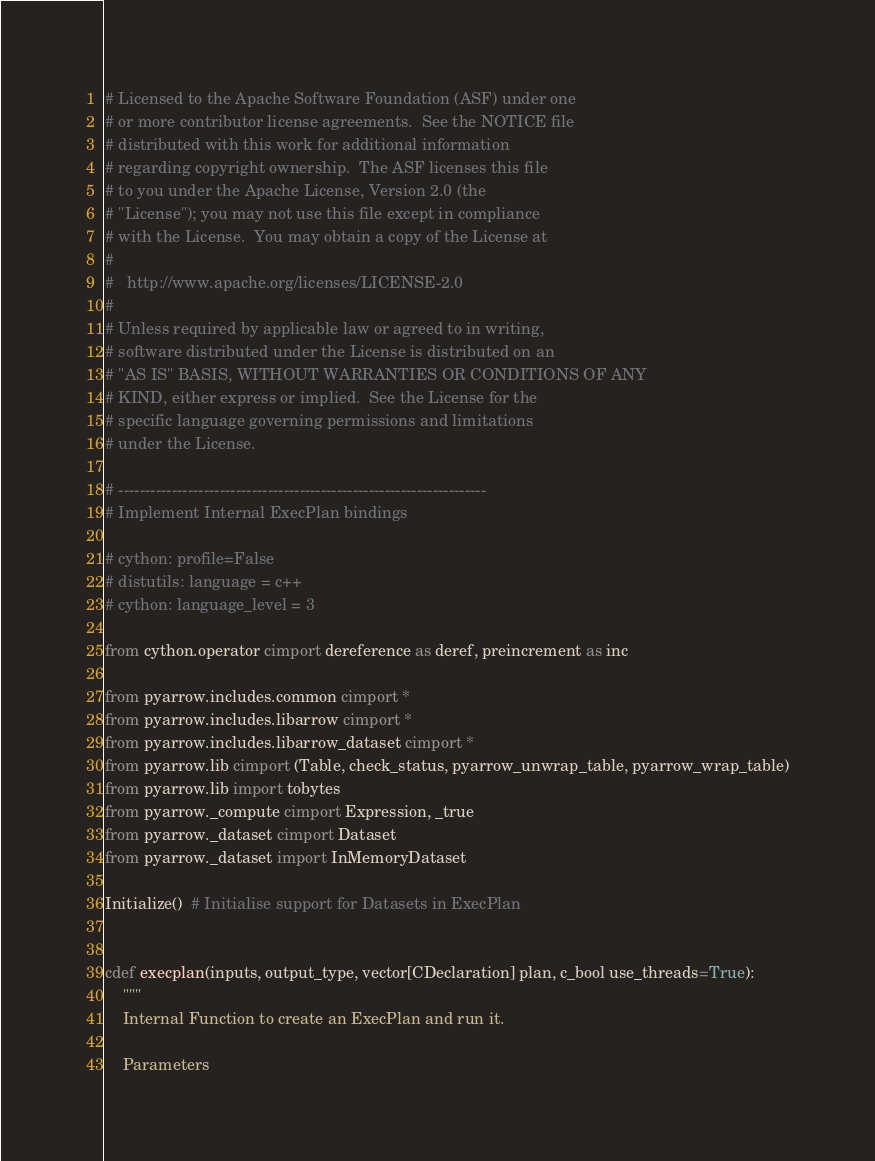Convert code to text. <code><loc_0><loc_0><loc_500><loc_500><_Cython_># Licensed to the Apache Software Foundation (ASF) under one
# or more contributor license agreements.  See the NOTICE file
# distributed with this work for additional information
# regarding copyright ownership.  The ASF licenses this file
# to you under the Apache License, Version 2.0 (the
# "License"); you may not use this file except in compliance
# with the License.  You may obtain a copy of the License at
#
#   http://www.apache.org/licenses/LICENSE-2.0
#
# Unless required by applicable law or agreed to in writing,
# software distributed under the License is distributed on an
# "AS IS" BASIS, WITHOUT WARRANTIES OR CONDITIONS OF ANY
# KIND, either express or implied.  See the License for the
# specific language governing permissions and limitations
# under the License.

# ---------------------------------------------------------------------
# Implement Internal ExecPlan bindings

# cython: profile=False
# distutils: language = c++
# cython: language_level = 3

from cython.operator cimport dereference as deref, preincrement as inc

from pyarrow.includes.common cimport *
from pyarrow.includes.libarrow cimport *
from pyarrow.includes.libarrow_dataset cimport *
from pyarrow.lib cimport (Table, check_status, pyarrow_unwrap_table, pyarrow_wrap_table)
from pyarrow.lib import tobytes
from pyarrow._compute cimport Expression, _true
from pyarrow._dataset cimport Dataset
from pyarrow._dataset import InMemoryDataset

Initialize()  # Initialise support for Datasets in ExecPlan


cdef execplan(inputs, output_type, vector[CDeclaration] plan, c_bool use_threads=True):
    """
    Internal Function to create an ExecPlan and run it.

    Parameters</code> 